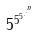Convert formula to latex. <formula><loc_0><loc_0><loc_500><loc_500>5 ^ { 5 ^ { 5 ^ { . ^ { . ^ { n } } } } }</formula> 